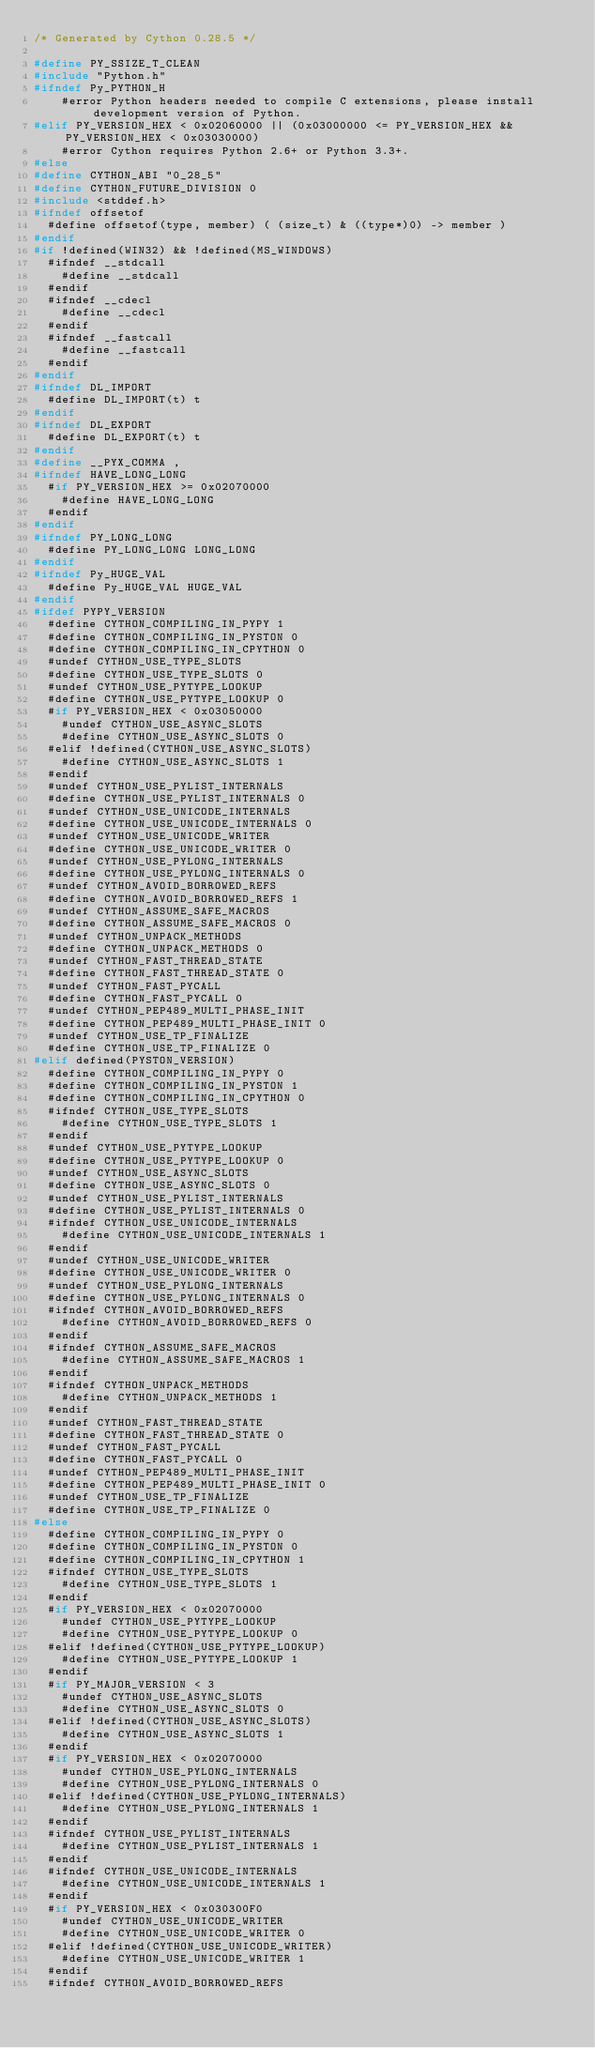<code> <loc_0><loc_0><loc_500><loc_500><_C_>/* Generated by Cython 0.28.5 */

#define PY_SSIZE_T_CLEAN
#include "Python.h"
#ifndef Py_PYTHON_H
    #error Python headers needed to compile C extensions, please install development version of Python.
#elif PY_VERSION_HEX < 0x02060000 || (0x03000000 <= PY_VERSION_HEX && PY_VERSION_HEX < 0x03030000)
    #error Cython requires Python 2.6+ or Python 3.3+.
#else
#define CYTHON_ABI "0_28_5"
#define CYTHON_FUTURE_DIVISION 0
#include <stddef.h>
#ifndef offsetof
  #define offsetof(type, member) ( (size_t) & ((type*)0) -> member )
#endif
#if !defined(WIN32) && !defined(MS_WINDOWS)
  #ifndef __stdcall
    #define __stdcall
  #endif
  #ifndef __cdecl
    #define __cdecl
  #endif
  #ifndef __fastcall
    #define __fastcall
  #endif
#endif
#ifndef DL_IMPORT
  #define DL_IMPORT(t) t
#endif
#ifndef DL_EXPORT
  #define DL_EXPORT(t) t
#endif
#define __PYX_COMMA ,
#ifndef HAVE_LONG_LONG
  #if PY_VERSION_HEX >= 0x02070000
    #define HAVE_LONG_LONG
  #endif
#endif
#ifndef PY_LONG_LONG
  #define PY_LONG_LONG LONG_LONG
#endif
#ifndef Py_HUGE_VAL
  #define Py_HUGE_VAL HUGE_VAL
#endif
#ifdef PYPY_VERSION
  #define CYTHON_COMPILING_IN_PYPY 1
  #define CYTHON_COMPILING_IN_PYSTON 0
  #define CYTHON_COMPILING_IN_CPYTHON 0
  #undef CYTHON_USE_TYPE_SLOTS
  #define CYTHON_USE_TYPE_SLOTS 0
  #undef CYTHON_USE_PYTYPE_LOOKUP
  #define CYTHON_USE_PYTYPE_LOOKUP 0
  #if PY_VERSION_HEX < 0x03050000
    #undef CYTHON_USE_ASYNC_SLOTS
    #define CYTHON_USE_ASYNC_SLOTS 0
  #elif !defined(CYTHON_USE_ASYNC_SLOTS)
    #define CYTHON_USE_ASYNC_SLOTS 1
  #endif
  #undef CYTHON_USE_PYLIST_INTERNALS
  #define CYTHON_USE_PYLIST_INTERNALS 0
  #undef CYTHON_USE_UNICODE_INTERNALS
  #define CYTHON_USE_UNICODE_INTERNALS 0
  #undef CYTHON_USE_UNICODE_WRITER
  #define CYTHON_USE_UNICODE_WRITER 0
  #undef CYTHON_USE_PYLONG_INTERNALS
  #define CYTHON_USE_PYLONG_INTERNALS 0
  #undef CYTHON_AVOID_BORROWED_REFS
  #define CYTHON_AVOID_BORROWED_REFS 1
  #undef CYTHON_ASSUME_SAFE_MACROS
  #define CYTHON_ASSUME_SAFE_MACROS 0
  #undef CYTHON_UNPACK_METHODS
  #define CYTHON_UNPACK_METHODS 0
  #undef CYTHON_FAST_THREAD_STATE
  #define CYTHON_FAST_THREAD_STATE 0
  #undef CYTHON_FAST_PYCALL
  #define CYTHON_FAST_PYCALL 0
  #undef CYTHON_PEP489_MULTI_PHASE_INIT
  #define CYTHON_PEP489_MULTI_PHASE_INIT 0
  #undef CYTHON_USE_TP_FINALIZE
  #define CYTHON_USE_TP_FINALIZE 0
#elif defined(PYSTON_VERSION)
  #define CYTHON_COMPILING_IN_PYPY 0
  #define CYTHON_COMPILING_IN_PYSTON 1
  #define CYTHON_COMPILING_IN_CPYTHON 0
  #ifndef CYTHON_USE_TYPE_SLOTS
    #define CYTHON_USE_TYPE_SLOTS 1
  #endif
  #undef CYTHON_USE_PYTYPE_LOOKUP
  #define CYTHON_USE_PYTYPE_LOOKUP 0
  #undef CYTHON_USE_ASYNC_SLOTS
  #define CYTHON_USE_ASYNC_SLOTS 0
  #undef CYTHON_USE_PYLIST_INTERNALS
  #define CYTHON_USE_PYLIST_INTERNALS 0
  #ifndef CYTHON_USE_UNICODE_INTERNALS
    #define CYTHON_USE_UNICODE_INTERNALS 1
  #endif
  #undef CYTHON_USE_UNICODE_WRITER
  #define CYTHON_USE_UNICODE_WRITER 0
  #undef CYTHON_USE_PYLONG_INTERNALS
  #define CYTHON_USE_PYLONG_INTERNALS 0
  #ifndef CYTHON_AVOID_BORROWED_REFS
    #define CYTHON_AVOID_BORROWED_REFS 0
  #endif
  #ifndef CYTHON_ASSUME_SAFE_MACROS
    #define CYTHON_ASSUME_SAFE_MACROS 1
  #endif
  #ifndef CYTHON_UNPACK_METHODS
    #define CYTHON_UNPACK_METHODS 1
  #endif
  #undef CYTHON_FAST_THREAD_STATE
  #define CYTHON_FAST_THREAD_STATE 0
  #undef CYTHON_FAST_PYCALL
  #define CYTHON_FAST_PYCALL 0
  #undef CYTHON_PEP489_MULTI_PHASE_INIT
  #define CYTHON_PEP489_MULTI_PHASE_INIT 0
  #undef CYTHON_USE_TP_FINALIZE
  #define CYTHON_USE_TP_FINALIZE 0
#else
  #define CYTHON_COMPILING_IN_PYPY 0
  #define CYTHON_COMPILING_IN_PYSTON 0
  #define CYTHON_COMPILING_IN_CPYTHON 1
  #ifndef CYTHON_USE_TYPE_SLOTS
    #define CYTHON_USE_TYPE_SLOTS 1
  #endif
  #if PY_VERSION_HEX < 0x02070000
    #undef CYTHON_USE_PYTYPE_LOOKUP
    #define CYTHON_USE_PYTYPE_LOOKUP 0
  #elif !defined(CYTHON_USE_PYTYPE_LOOKUP)
    #define CYTHON_USE_PYTYPE_LOOKUP 1
  #endif
  #if PY_MAJOR_VERSION < 3
    #undef CYTHON_USE_ASYNC_SLOTS
    #define CYTHON_USE_ASYNC_SLOTS 0
  #elif !defined(CYTHON_USE_ASYNC_SLOTS)
    #define CYTHON_USE_ASYNC_SLOTS 1
  #endif
  #if PY_VERSION_HEX < 0x02070000
    #undef CYTHON_USE_PYLONG_INTERNALS
    #define CYTHON_USE_PYLONG_INTERNALS 0
  #elif !defined(CYTHON_USE_PYLONG_INTERNALS)
    #define CYTHON_USE_PYLONG_INTERNALS 1
  #endif
  #ifndef CYTHON_USE_PYLIST_INTERNALS
    #define CYTHON_USE_PYLIST_INTERNALS 1
  #endif
  #ifndef CYTHON_USE_UNICODE_INTERNALS
    #define CYTHON_USE_UNICODE_INTERNALS 1
  #endif
  #if PY_VERSION_HEX < 0x030300F0
    #undef CYTHON_USE_UNICODE_WRITER
    #define CYTHON_USE_UNICODE_WRITER 0
  #elif !defined(CYTHON_USE_UNICODE_WRITER)
    #define CYTHON_USE_UNICODE_WRITER 1
  #endif
  #ifndef CYTHON_AVOID_BORROWED_REFS</code> 